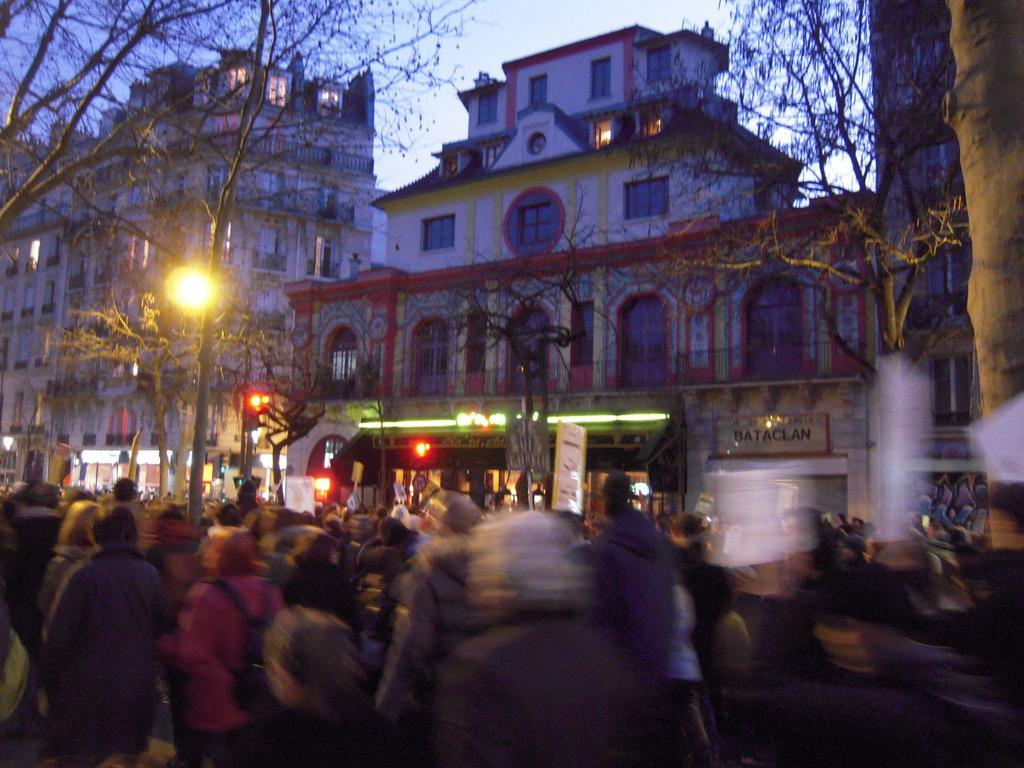Could you give a brief overview of what you see in this image? In this image I can see some people. On the left and right side, I can see the trees. In the background, I can see the buildings and the sky. 